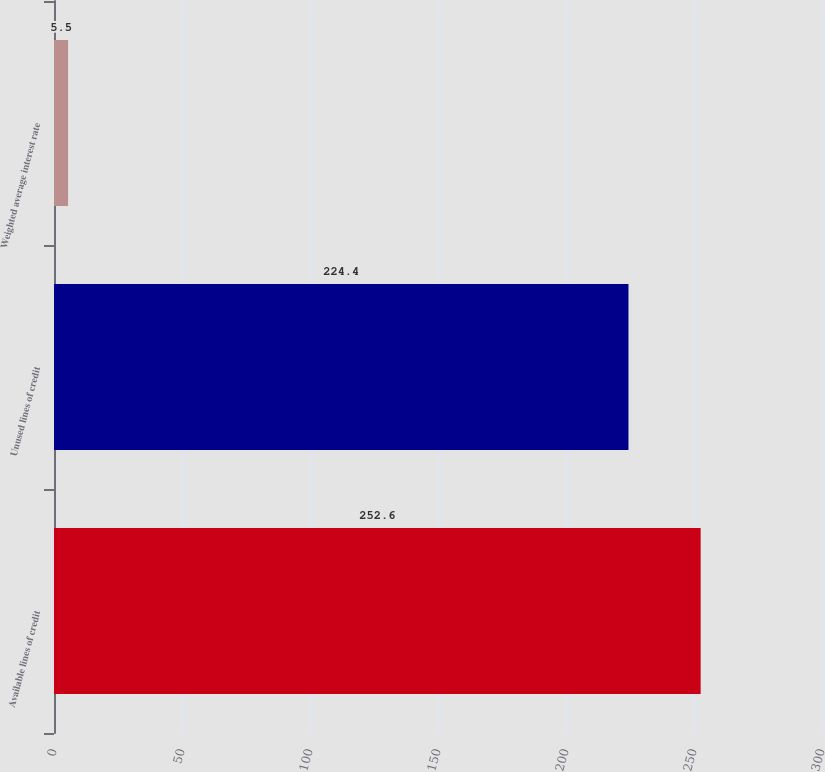<chart> <loc_0><loc_0><loc_500><loc_500><bar_chart><fcel>Available lines of credit<fcel>Unused lines of credit<fcel>Weighted average interest rate<nl><fcel>252.6<fcel>224.4<fcel>5.5<nl></chart> 